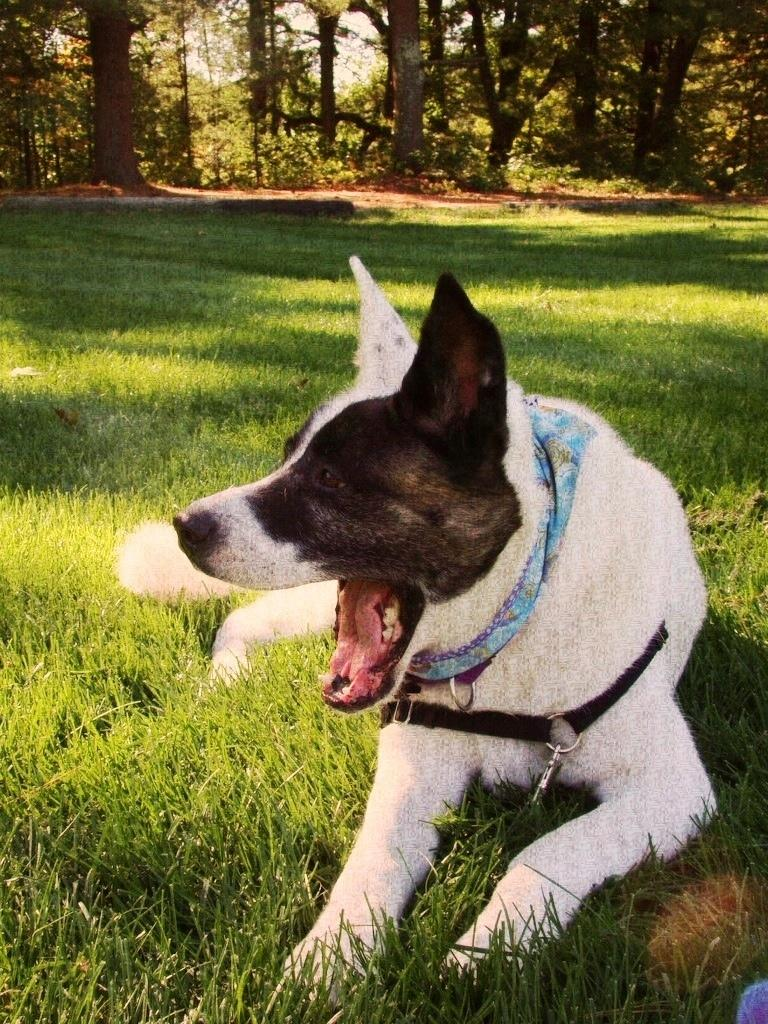What type of animal is in the image? There is a dog in the image. Where is the dog located? The dog is sitting on the grass. What can be seen in the background of the image? There are trees in the background of the image. What type of pollution is visible in the image? There is no pollution visible in the image; it features a dog sitting on the grass with trees in the background. What subject is the dog teaching in the image? There is no indication in the image that the dog is teaching any subject. 